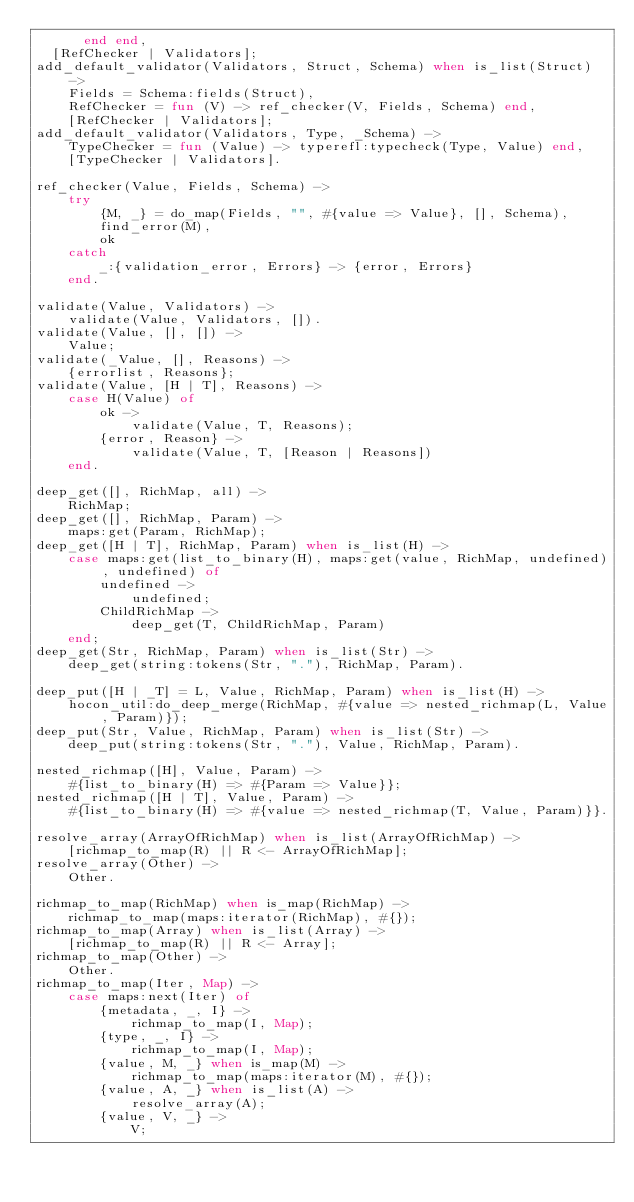<code> <loc_0><loc_0><loc_500><loc_500><_Erlang_>      end end,
  [RefChecker | Validators];
add_default_validator(Validators, Struct, Schema) when is_list(Struct) ->
    Fields = Schema:fields(Struct),
    RefChecker = fun (V) -> ref_checker(V, Fields, Schema) end,
    [RefChecker | Validators];
add_default_validator(Validators, Type, _Schema) ->
    TypeChecker = fun (Value) -> typerefl:typecheck(Type, Value) end,
    [TypeChecker | Validators].

ref_checker(Value, Fields, Schema) ->
    try
        {M, _} = do_map(Fields, "", #{value => Value}, [], Schema),
        find_error(M),
        ok
    catch
        _:{validation_error, Errors} -> {error, Errors}
    end.

validate(Value, Validators) ->
    validate(Value, Validators, []).
validate(Value, [], []) ->
    Value;
validate(_Value, [], Reasons) ->
    {errorlist, Reasons};
validate(Value, [H | T], Reasons) ->
    case H(Value) of
        ok ->
            validate(Value, T, Reasons);
        {error, Reason} ->
            validate(Value, T, [Reason | Reasons])
    end.

deep_get([], RichMap, all) ->
    RichMap;
deep_get([], RichMap, Param) ->
    maps:get(Param, RichMap);
deep_get([H | T], RichMap, Param) when is_list(H) ->
    case maps:get(list_to_binary(H), maps:get(value, RichMap, undefined), undefined) of
        undefined ->
            undefined;
        ChildRichMap ->
            deep_get(T, ChildRichMap, Param)
    end;
deep_get(Str, RichMap, Param) when is_list(Str) ->
    deep_get(string:tokens(Str, "."), RichMap, Param).

deep_put([H | _T] = L, Value, RichMap, Param) when is_list(H) ->
    hocon_util:do_deep_merge(RichMap, #{value => nested_richmap(L, Value, Param)});
deep_put(Str, Value, RichMap, Param) when is_list(Str) ->
    deep_put(string:tokens(Str, "."), Value, RichMap, Param).

nested_richmap([H], Value, Param) ->
    #{list_to_binary(H) => #{Param => Value}};
nested_richmap([H | T], Value, Param) ->
    #{list_to_binary(H) => #{value => nested_richmap(T, Value, Param)}}.

resolve_array(ArrayOfRichMap) when is_list(ArrayOfRichMap) ->
    [richmap_to_map(R) || R <- ArrayOfRichMap];
resolve_array(Other) ->
    Other.

richmap_to_map(RichMap) when is_map(RichMap) ->
    richmap_to_map(maps:iterator(RichMap), #{});
richmap_to_map(Array) when is_list(Array) ->
    [richmap_to_map(R) || R <- Array];
richmap_to_map(Other) ->
    Other.
richmap_to_map(Iter, Map) ->
    case maps:next(Iter) of
        {metadata, _, I} ->
            richmap_to_map(I, Map);
        {type, _, I} ->
            richmap_to_map(I, Map);
        {value, M, _} when is_map(M) ->
            richmap_to_map(maps:iterator(M), #{});
        {value, A, _} when is_list(A) ->
            resolve_array(A);
        {value, V, _} ->
            V;</code> 